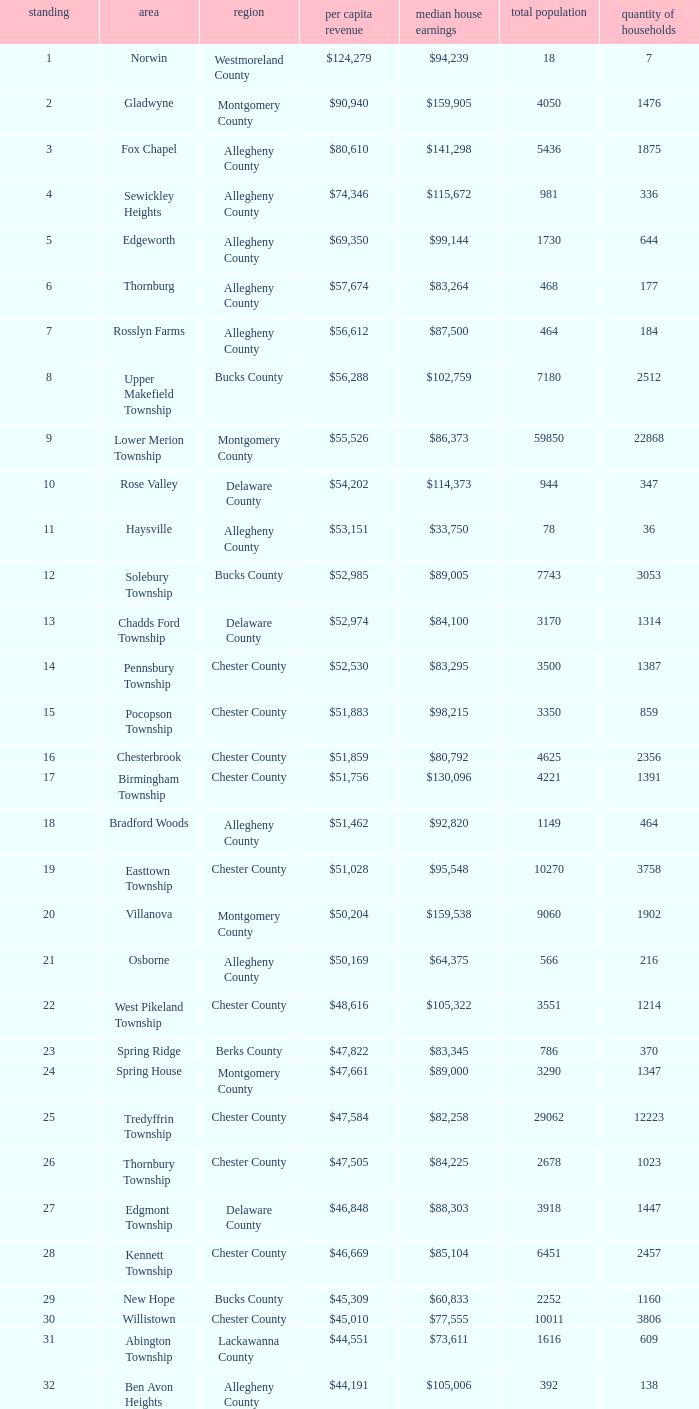What county has 2053 households?  Chester County. 